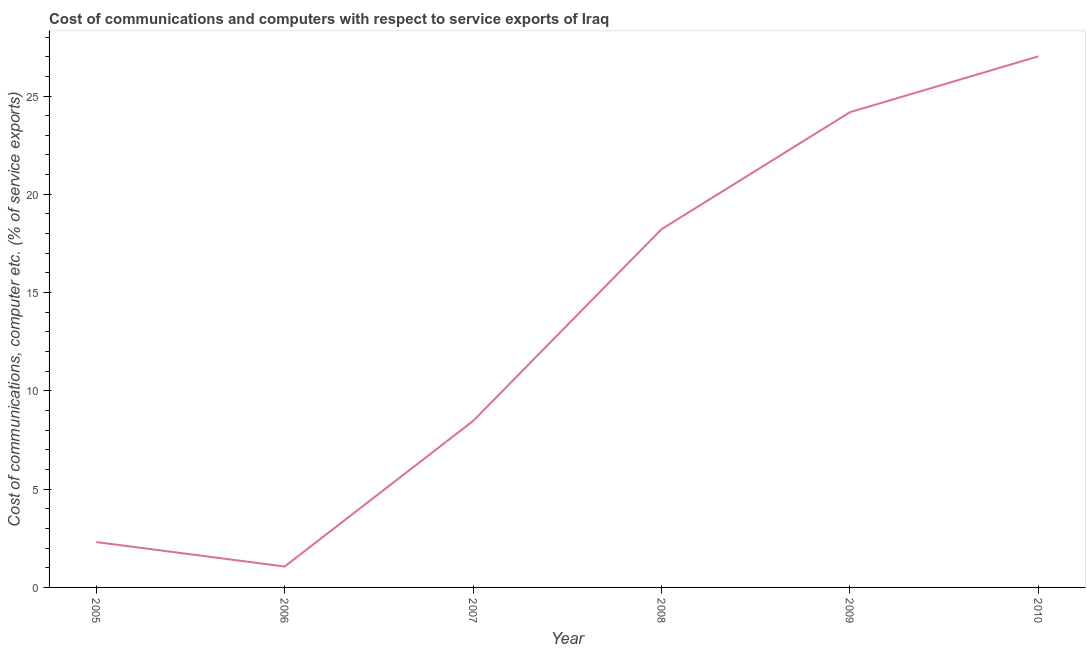What is the cost of communications and computer in 2010?
Provide a succinct answer. 27.02. Across all years, what is the maximum cost of communications and computer?
Offer a terse response. 27.02. Across all years, what is the minimum cost of communications and computer?
Give a very brief answer. 1.06. In which year was the cost of communications and computer maximum?
Offer a very short reply. 2010. In which year was the cost of communications and computer minimum?
Ensure brevity in your answer.  2006. What is the sum of the cost of communications and computer?
Keep it short and to the point. 81.26. What is the difference between the cost of communications and computer in 2005 and 2007?
Your answer should be very brief. -6.16. What is the average cost of communications and computer per year?
Your answer should be very brief. 13.54. What is the median cost of communications and computer?
Provide a short and direct response. 13.35. What is the ratio of the cost of communications and computer in 2005 to that in 2007?
Offer a terse response. 0.27. Is the cost of communications and computer in 2006 less than that in 2009?
Your answer should be compact. Yes. Is the difference between the cost of communications and computer in 2005 and 2006 greater than the difference between any two years?
Offer a terse response. No. What is the difference between the highest and the second highest cost of communications and computer?
Give a very brief answer. 2.84. Is the sum of the cost of communications and computer in 2007 and 2008 greater than the maximum cost of communications and computer across all years?
Your answer should be very brief. No. What is the difference between the highest and the lowest cost of communications and computer?
Offer a terse response. 25.95. Does the cost of communications and computer monotonically increase over the years?
Offer a terse response. No. Are the values on the major ticks of Y-axis written in scientific E-notation?
Provide a succinct answer. No. What is the title of the graph?
Your answer should be very brief. Cost of communications and computers with respect to service exports of Iraq. What is the label or title of the X-axis?
Your answer should be very brief. Year. What is the label or title of the Y-axis?
Your answer should be compact. Cost of communications, computer etc. (% of service exports). What is the Cost of communications, computer etc. (% of service exports) of 2005?
Make the answer very short. 2.31. What is the Cost of communications, computer etc. (% of service exports) in 2006?
Your response must be concise. 1.06. What is the Cost of communications, computer etc. (% of service exports) in 2007?
Give a very brief answer. 8.47. What is the Cost of communications, computer etc. (% of service exports) of 2008?
Your answer should be very brief. 18.22. What is the Cost of communications, computer etc. (% of service exports) in 2009?
Make the answer very short. 24.18. What is the Cost of communications, computer etc. (% of service exports) in 2010?
Provide a succinct answer. 27.02. What is the difference between the Cost of communications, computer etc. (% of service exports) in 2005 and 2006?
Ensure brevity in your answer.  1.24. What is the difference between the Cost of communications, computer etc. (% of service exports) in 2005 and 2007?
Keep it short and to the point. -6.16. What is the difference between the Cost of communications, computer etc. (% of service exports) in 2005 and 2008?
Your response must be concise. -15.92. What is the difference between the Cost of communications, computer etc. (% of service exports) in 2005 and 2009?
Your answer should be compact. -21.87. What is the difference between the Cost of communications, computer etc. (% of service exports) in 2005 and 2010?
Provide a short and direct response. -24.71. What is the difference between the Cost of communications, computer etc. (% of service exports) in 2006 and 2007?
Ensure brevity in your answer.  -7.4. What is the difference between the Cost of communications, computer etc. (% of service exports) in 2006 and 2008?
Ensure brevity in your answer.  -17.16. What is the difference between the Cost of communications, computer etc. (% of service exports) in 2006 and 2009?
Make the answer very short. -23.11. What is the difference between the Cost of communications, computer etc. (% of service exports) in 2006 and 2010?
Your answer should be very brief. -25.95. What is the difference between the Cost of communications, computer etc. (% of service exports) in 2007 and 2008?
Provide a short and direct response. -9.76. What is the difference between the Cost of communications, computer etc. (% of service exports) in 2007 and 2009?
Make the answer very short. -15.71. What is the difference between the Cost of communications, computer etc. (% of service exports) in 2007 and 2010?
Your answer should be very brief. -18.55. What is the difference between the Cost of communications, computer etc. (% of service exports) in 2008 and 2009?
Ensure brevity in your answer.  -5.95. What is the difference between the Cost of communications, computer etc. (% of service exports) in 2008 and 2010?
Keep it short and to the point. -8.79. What is the difference between the Cost of communications, computer etc. (% of service exports) in 2009 and 2010?
Keep it short and to the point. -2.84. What is the ratio of the Cost of communications, computer etc. (% of service exports) in 2005 to that in 2006?
Give a very brief answer. 2.17. What is the ratio of the Cost of communications, computer etc. (% of service exports) in 2005 to that in 2007?
Keep it short and to the point. 0.27. What is the ratio of the Cost of communications, computer etc. (% of service exports) in 2005 to that in 2008?
Make the answer very short. 0.13. What is the ratio of the Cost of communications, computer etc. (% of service exports) in 2005 to that in 2009?
Your answer should be compact. 0.1. What is the ratio of the Cost of communications, computer etc. (% of service exports) in 2005 to that in 2010?
Make the answer very short. 0.09. What is the ratio of the Cost of communications, computer etc. (% of service exports) in 2006 to that in 2007?
Your answer should be compact. 0.13. What is the ratio of the Cost of communications, computer etc. (% of service exports) in 2006 to that in 2008?
Offer a terse response. 0.06. What is the ratio of the Cost of communications, computer etc. (% of service exports) in 2006 to that in 2009?
Give a very brief answer. 0.04. What is the ratio of the Cost of communications, computer etc. (% of service exports) in 2006 to that in 2010?
Your response must be concise. 0.04. What is the ratio of the Cost of communications, computer etc. (% of service exports) in 2007 to that in 2008?
Keep it short and to the point. 0.47. What is the ratio of the Cost of communications, computer etc. (% of service exports) in 2007 to that in 2009?
Provide a short and direct response. 0.35. What is the ratio of the Cost of communications, computer etc. (% of service exports) in 2007 to that in 2010?
Your answer should be compact. 0.31. What is the ratio of the Cost of communications, computer etc. (% of service exports) in 2008 to that in 2009?
Make the answer very short. 0.75. What is the ratio of the Cost of communications, computer etc. (% of service exports) in 2008 to that in 2010?
Your response must be concise. 0.67. What is the ratio of the Cost of communications, computer etc. (% of service exports) in 2009 to that in 2010?
Provide a succinct answer. 0.9. 